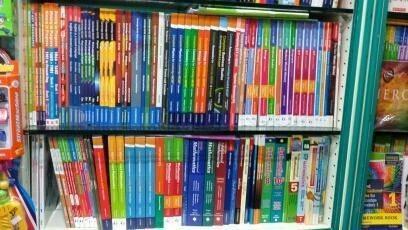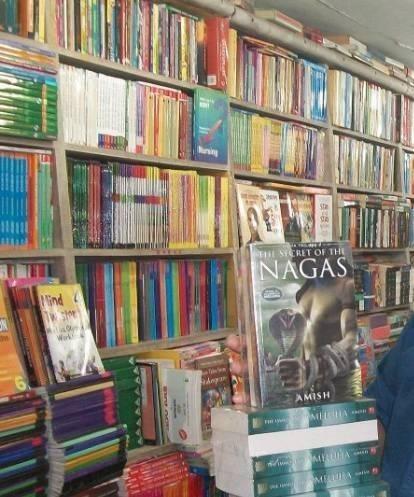The first image is the image on the left, the second image is the image on the right. Given the left and right images, does the statement "Both images are have a few bookshelves close up, and no people." hold true? Answer yes or no. Yes. The first image is the image on the left, the second image is the image on the right. Given the left and right images, does the statement "One image shows book-type items displayed vertically on shelves viewed head-on, and neither image shows people standing in a store." hold true? Answer yes or no. Yes. 